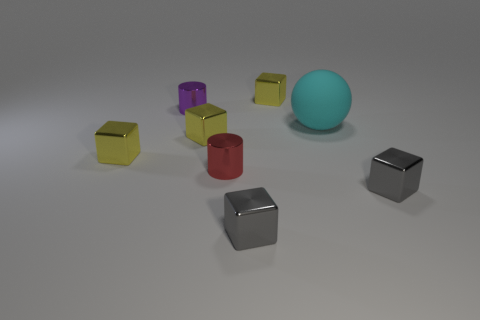Are any tiny blue metallic objects visible?
Provide a succinct answer. No. What number of other things are there of the same shape as the purple object?
Your answer should be very brief. 1. Is the color of the thing that is left of the purple cylinder the same as the tiny block behind the tiny purple cylinder?
Your answer should be compact. Yes. What size is the cyan sphere behind the small gray thing in front of the metal object that is to the right of the big matte ball?
Your answer should be compact. Large. What is the shape of the shiny thing that is behind the large rubber sphere and to the left of the tiny red metal cylinder?
Make the answer very short. Cylinder. Is the number of tiny gray things that are behind the rubber object the same as the number of purple cylinders that are to the left of the small purple metallic cylinder?
Give a very brief answer. Yes. Is there a gray thing made of the same material as the small purple cylinder?
Your response must be concise. Yes. Is the tiny gray object on the left side of the big matte thing made of the same material as the sphere?
Give a very brief answer. No. What is the size of the yellow metallic cube that is right of the purple cylinder and in front of the cyan rubber object?
Offer a terse response. Small. The large ball has what color?
Offer a terse response. Cyan. 